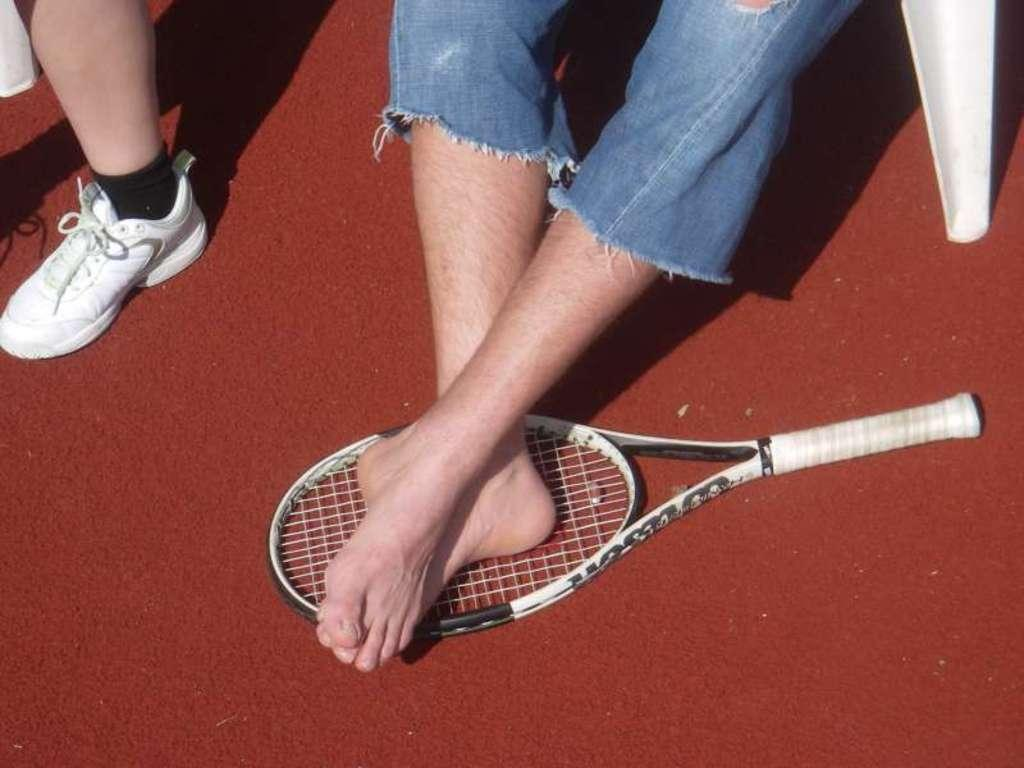What animal is present in the picture? There is a bat in the picture. What part of a person can be seen in the picture? There are person's legs in the picture. What type of footwear is visible in the picture? There is a white-colored shoe in the picture. What type of harmony can be heard in the image? There is no sound or music present in the image, so it is not possible to determine if any harmony can be heard. 